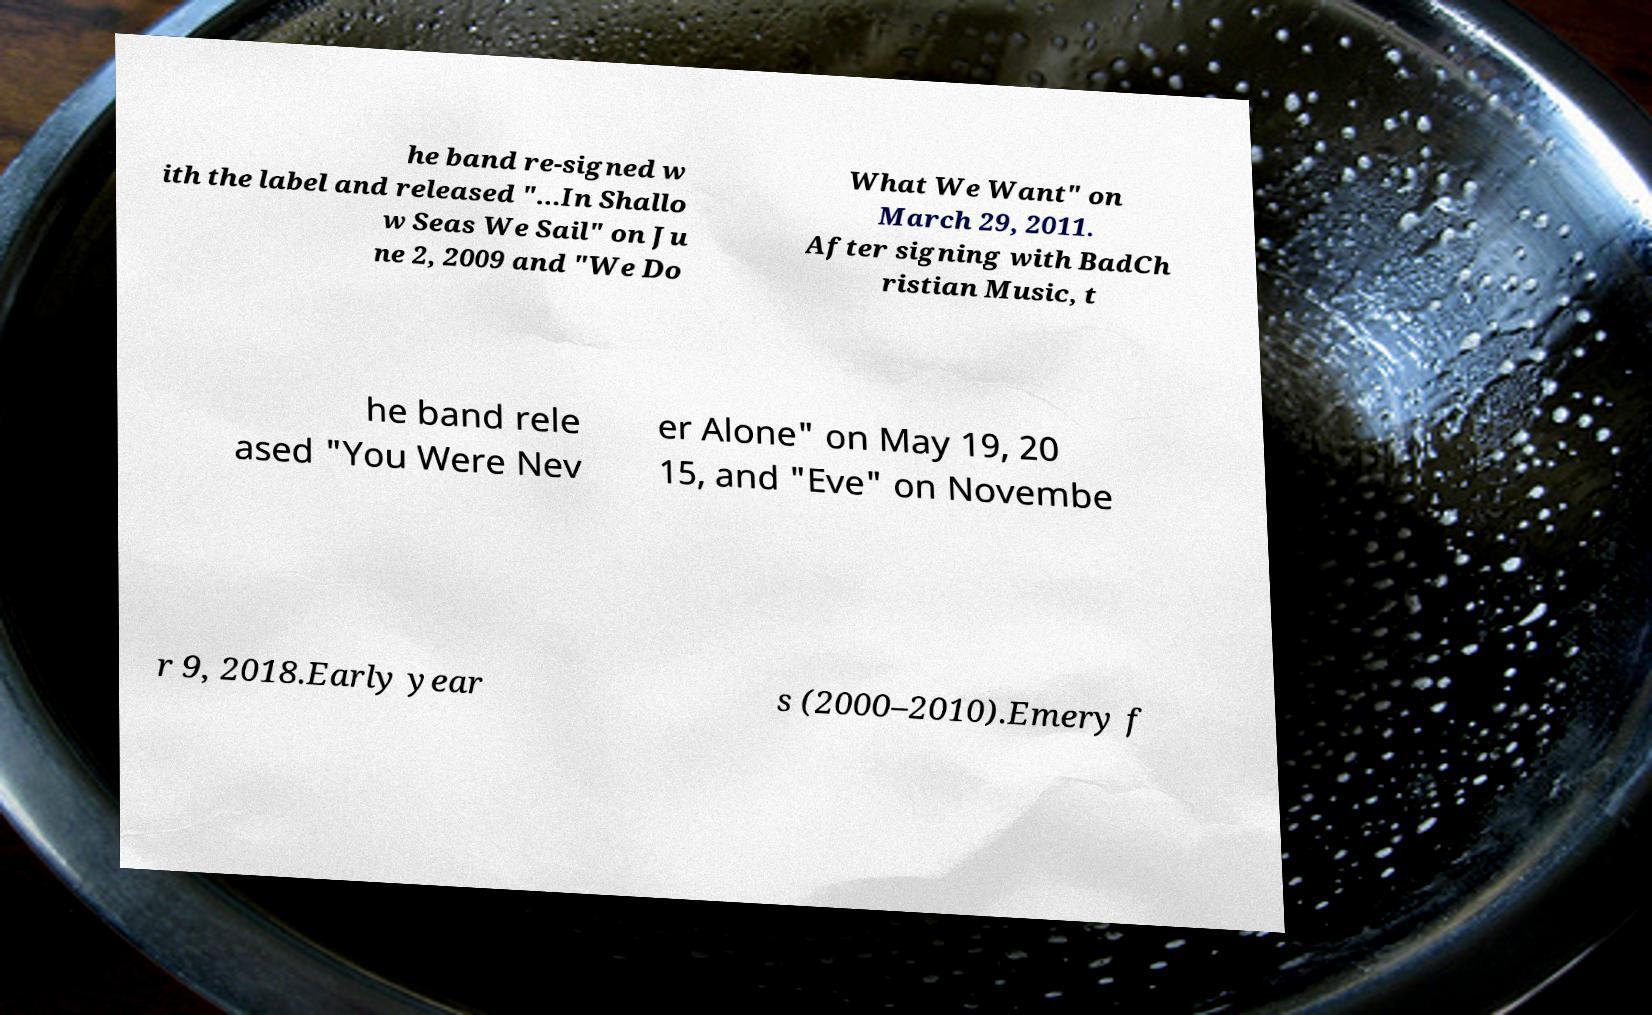Could you assist in decoding the text presented in this image and type it out clearly? he band re-signed w ith the label and released "...In Shallo w Seas We Sail" on Ju ne 2, 2009 and "We Do What We Want" on March 29, 2011. After signing with BadCh ristian Music, t he band rele ased "You Were Nev er Alone" on May 19, 20 15, and "Eve" on Novembe r 9, 2018.Early year s (2000–2010).Emery f 